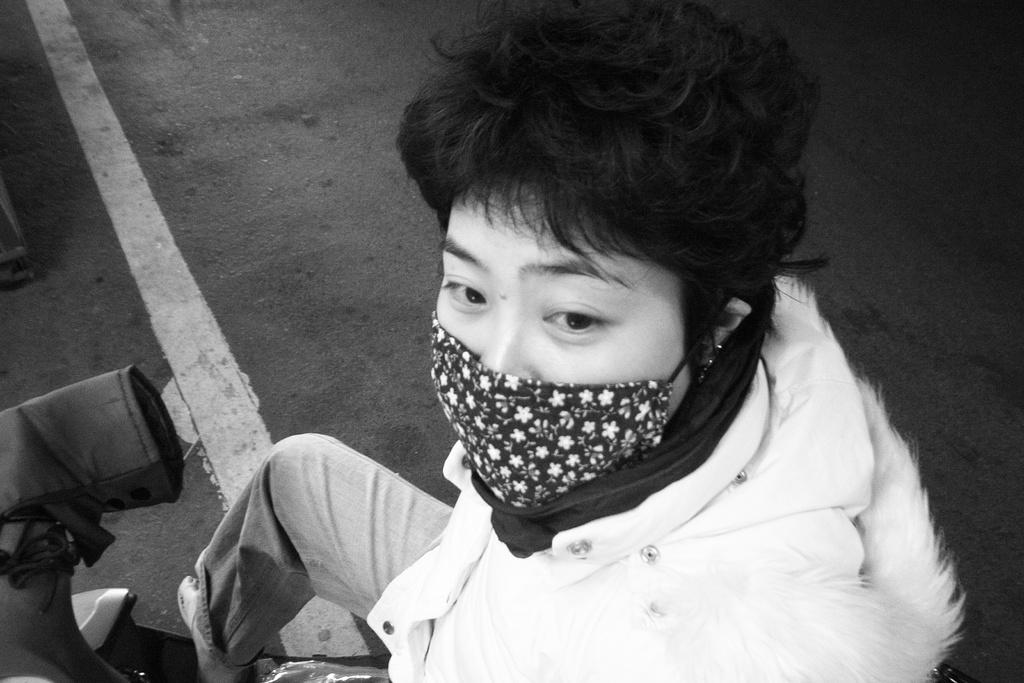What is the main subject of the image? There is a person in the image. Can you describe what the person is wearing? The person is wearing a nose mask. What color is the flag on the person's stomach in the image? There is no flag present on the person's stomach in the image. 